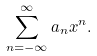Convert formula to latex. <formula><loc_0><loc_0><loc_500><loc_500>\sum _ { n = - \infty } ^ { \infty } a _ { n } x ^ { n } .</formula> 